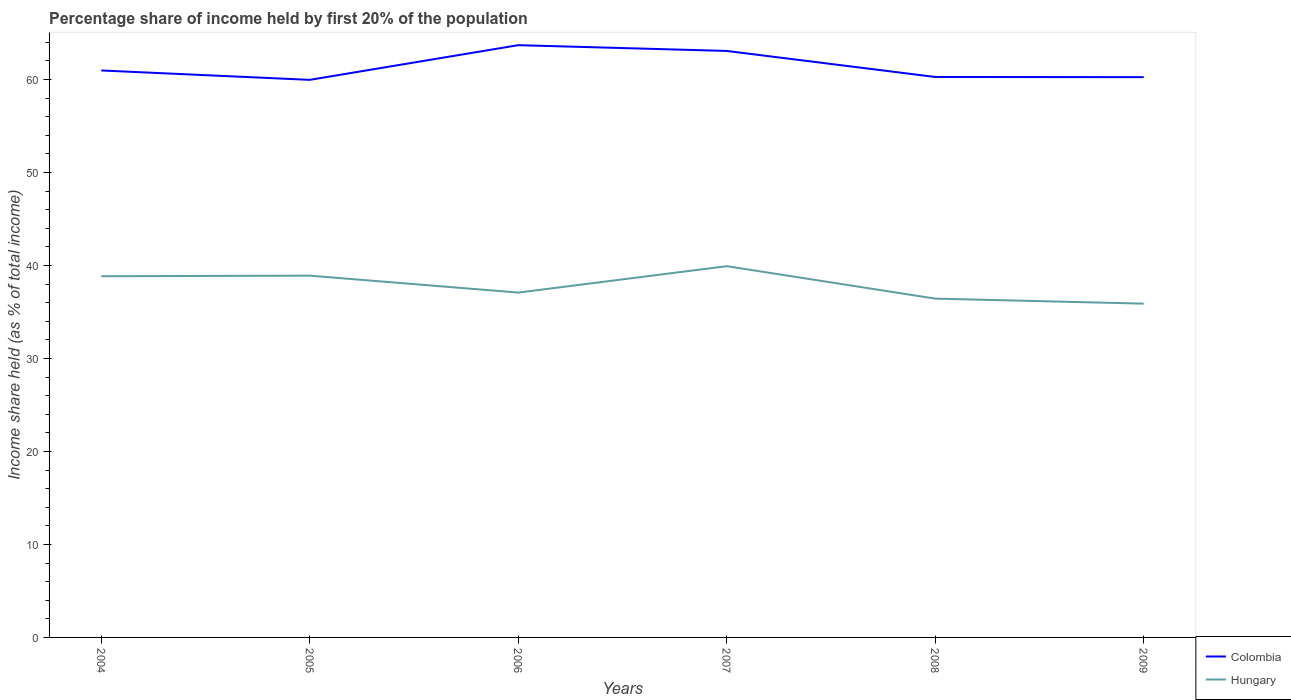How many different coloured lines are there?
Give a very brief answer. 2. Does the line corresponding to Hungary intersect with the line corresponding to Colombia?
Your answer should be compact. No. Is the number of lines equal to the number of legend labels?
Make the answer very short. Yes. Across all years, what is the maximum share of income held by first 20% of the population in Colombia?
Offer a terse response. 59.97. In which year was the share of income held by first 20% of the population in Colombia maximum?
Keep it short and to the point. 2005. What is the total share of income held by first 20% of the population in Colombia in the graph?
Give a very brief answer. 0.72. What is the difference between the highest and the second highest share of income held by first 20% of the population in Hungary?
Your answer should be compact. 4.03. Is the share of income held by first 20% of the population in Hungary strictly greater than the share of income held by first 20% of the population in Colombia over the years?
Ensure brevity in your answer.  Yes. How many lines are there?
Keep it short and to the point. 2. Does the graph contain any zero values?
Give a very brief answer. No. Does the graph contain grids?
Your response must be concise. No. Where does the legend appear in the graph?
Keep it short and to the point. Bottom right. How many legend labels are there?
Give a very brief answer. 2. How are the legend labels stacked?
Offer a very short reply. Vertical. What is the title of the graph?
Provide a short and direct response. Percentage share of income held by first 20% of the population. What is the label or title of the X-axis?
Offer a very short reply. Years. What is the label or title of the Y-axis?
Ensure brevity in your answer.  Income share held (as % of total income). What is the Income share held (as % of total income) of Colombia in 2004?
Your response must be concise. 60.98. What is the Income share held (as % of total income) in Hungary in 2004?
Provide a succinct answer. 38.85. What is the Income share held (as % of total income) in Colombia in 2005?
Ensure brevity in your answer.  59.97. What is the Income share held (as % of total income) of Hungary in 2005?
Keep it short and to the point. 38.91. What is the Income share held (as % of total income) of Colombia in 2006?
Ensure brevity in your answer.  63.7. What is the Income share held (as % of total income) in Hungary in 2006?
Provide a succinct answer. 37.09. What is the Income share held (as % of total income) in Colombia in 2007?
Your response must be concise. 63.08. What is the Income share held (as % of total income) of Hungary in 2007?
Your answer should be compact. 39.93. What is the Income share held (as % of total income) of Colombia in 2008?
Make the answer very short. 60.28. What is the Income share held (as % of total income) in Hungary in 2008?
Provide a short and direct response. 36.44. What is the Income share held (as % of total income) in Colombia in 2009?
Offer a very short reply. 60.26. What is the Income share held (as % of total income) of Hungary in 2009?
Give a very brief answer. 35.9. Across all years, what is the maximum Income share held (as % of total income) in Colombia?
Offer a very short reply. 63.7. Across all years, what is the maximum Income share held (as % of total income) of Hungary?
Give a very brief answer. 39.93. Across all years, what is the minimum Income share held (as % of total income) in Colombia?
Your answer should be very brief. 59.97. Across all years, what is the minimum Income share held (as % of total income) in Hungary?
Offer a very short reply. 35.9. What is the total Income share held (as % of total income) in Colombia in the graph?
Keep it short and to the point. 368.27. What is the total Income share held (as % of total income) in Hungary in the graph?
Keep it short and to the point. 227.12. What is the difference between the Income share held (as % of total income) of Hungary in 2004 and that in 2005?
Your response must be concise. -0.06. What is the difference between the Income share held (as % of total income) in Colombia in 2004 and that in 2006?
Offer a terse response. -2.72. What is the difference between the Income share held (as % of total income) of Hungary in 2004 and that in 2006?
Offer a very short reply. 1.76. What is the difference between the Income share held (as % of total income) in Colombia in 2004 and that in 2007?
Make the answer very short. -2.1. What is the difference between the Income share held (as % of total income) in Hungary in 2004 and that in 2007?
Provide a succinct answer. -1.08. What is the difference between the Income share held (as % of total income) in Hungary in 2004 and that in 2008?
Your response must be concise. 2.41. What is the difference between the Income share held (as % of total income) in Colombia in 2004 and that in 2009?
Offer a very short reply. 0.72. What is the difference between the Income share held (as % of total income) of Hungary in 2004 and that in 2009?
Make the answer very short. 2.95. What is the difference between the Income share held (as % of total income) in Colombia in 2005 and that in 2006?
Keep it short and to the point. -3.73. What is the difference between the Income share held (as % of total income) in Hungary in 2005 and that in 2006?
Ensure brevity in your answer.  1.82. What is the difference between the Income share held (as % of total income) of Colombia in 2005 and that in 2007?
Your response must be concise. -3.11. What is the difference between the Income share held (as % of total income) in Hungary in 2005 and that in 2007?
Provide a succinct answer. -1.02. What is the difference between the Income share held (as % of total income) in Colombia in 2005 and that in 2008?
Provide a succinct answer. -0.31. What is the difference between the Income share held (as % of total income) of Hungary in 2005 and that in 2008?
Provide a short and direct response. 2.47. What is the difference between the Income share held (as % of total income) in Colombia in 2005 and that in 2009?
Provide a succinct answer. -0.29. What is the difference between the Income share held (as % of total income) of Hungary in 2005 and that in 2009?
Make the answer very short. 3.01. What is the difference between the Income share held (as % of total income) in Colombia in 2006 and that in 2007?
Offer a very short reply. 0.62. What is the difference between the Income share held (as % of total income) of Hungary in 2006 and that in 2007?
Offer a very short reply. -2.84. What is the difference between the Income share held (as % of total income) in Colombia in 2006 and that in 2008?
Your response must be concise. 3.42. What is the difference between the Income share held (as % of total income) in Hungary in 2006 and that in 2008?
Your answer should be compact. 0.65. What is the difference between the Income share held (as % of total income) in Colombia in 2006 and that in 2009?
Your answer should be very brief. 3.44. What is the difference between the Income share held (as % of total income) in Hungary in 2006 and that in 2009?
Provide a succinct answer. 1.19. What is the difference between the Income share held (as % of total income) in Colombia in 2007 and that in 2008?
Offer a very short reply. 2.8. What is the difference between the Income share held (as % of total income) of Hungary in 2007 and that in 2008?
Offer a very short reply. 3.49. What is the difference between the Income share held (as % of total income) in Colombia in 2007 and that in 2009?
Your answer should be very brief. 2.82. What is the difference between the Income share held (as % of total income) in Hungary in 2007 and that in 2009?
Your response must be concise. 4.03. What is the difference between the Income share held (as % of total income) of Colombia in 2008 and that in 2009?
Provide a short and direct response. 0.02. What is the difference between the Income share held (as % of total income) of Hungary in 2008 and that in 2009?
Give a very brief answer. 0.54. What is the difference between the Income share held (as % of total income) in Colombia in 2004 and the Income share held (as % of total income) in Hungary in 2005?
Give a very brief answer. 22.07. What is the difference between the Income share held (as % of total income) of Colombia in 2004 and the Income share held (as % of total income) of Hungary in 2006?
Your answer should be very brief. 23.89. What is the difference between the Income share held (as % of total income) in Colombia in 2004 and the Income share held (as % of total income) in Hungary in 2007?
Give a very brief answer. 21.05. What is the difference between the Income share held (as % of total income) of Colombia in 2004 and the Income share held (as % of total income) of Hungary in 2008?
Your answer should be compact. 24.54. What is the difference between the Income share held (as % of total income) in Colombia in 2004 and the Income share held (as % of total income) in Hungary in 2009?
Make the answer very short. 25.08. What is the difference between the Income share held (as % of total income) of Colombia in 2005 and the Income share held (as % of total income) of Hungary in 2006?
Keep it short and to the point. 22.88. What is the difference between the Income share held (as % of total income) of Colombia in 2005 and the Income share held (as % of total income) of Hungary in 2007?
Offer a very short reply. 20.04. What is the difference between the Income share held (as % of total income) in Colombia in 2005 and the Income share held (as % of total income) in Hungary in 2008?
Give a very brief answer. 23.53. What is the difference between the Income share held (as % of total income) of Colombia in 2005 and the Income share held (as % of total income) of Hungary in 2009?
Offer a very short reply. 24.07. What is the difference between the Income share held (as % of total income) of Colombia in 2006 and the Income share held (as % of total income) of Hungary in 2007?
Make the answer very short. 23.77. What is the difference between the Income share held (as % of total income) in Colombia in 2006 and the Income share held (as % of total income) in Hungary in 2008?
Your answer should be compact. 27.26. What is the difference between the Income share held (as % of total income) in Colombia in 2006 and the Income share held (as % of total income) in Hungary in 2009?
Make the answer very short. 27.8. What is the difference between the Income share held (as % of total income) in Colombia in 2007 and the Income share held (as % of total income) in Hungary in 2008?
Your response must be concise. 26.64. What is the difference between the Income share held (as % of total income) in Colombia in 2007 and the Income share held (as % of total income) in Hungary in 2009?
Your response must be concise. 27.18. What is the difference between the Income share held (as % of total income) in Colombia in 2008 and the Income share held (as % of total income) in Hungary in 2009?
Make the answer very short. 24.38. What is the average Income share held (as % of total income) in Colombia per year?
Offer a terse response. 61.38. What is the average Income share held (as % of total income) in Hungary per year?
Your answer should be very brief. 37.85. In the year 2004, what is the difference between the Income share held (as % of total income) in Colombia and Income share held (as % of total income) in Hungary?
Ensure brevity in your answer.  22.13. In the year 2005, what is the difference between the Income share held (as % of total income) in Colombia and Income share held (as % of total income) in Hungary?
Provide a short and direct response. 21.06. In the year 2006, what is the difference between the Income share held (as % of total income) in Colombia and Income share held (as % of total income) in Hungary?
Provide a succinct answer. 26.61. In the year 2007, what is the difference between the Income share held (as % of total income) in Colombia and Income share held (as % of total income) in Hungary?
Your response must be concise. 23.15. In the year 2008, what is the difference between the Income share held (as % of total income) of Colombia and Income share held (as % of total income) of Hungary?
Ensure brevity in your answer.  23.84. In the year 2009, what is the difference between the Income share held (as % of total income) in Colombia and Income share held (as % of total income) in Hungary?
Make the answer very short. 24.36. What is the ratio of the Income share held (as % of total income) in Colombia in 2004 to that in 2005?
Keep it short and to the point. 1.02. What is the ratio of the Income share held (as % of total income) of Hungary in 2004 to that in 2005?
Keep it short and to the point. 1. What is the ratio of the Income share held (as % of total income) in Colombia in 2004 to that in 2006?
Make the answer very short. 0.96. What is the ratio of the Income share held (as % of total income) of Hungary in 2004 to that in 2006?
Offer a terse response. 1.05. What is the ratio of the Income share held (as % of total income) in Colombia in 2004 to that in 2007?
Offer a very short reply. 0.97. What is the ratio of the Income share held (as % of total income) in Hungary in 2004 to that in 2007?
Your response must be concise. 0.97. What is the ratio of the Income share held (as % of total income) in Colombia in 2004 to that in 2008?
Offer a terse response. 1.01. What is the ratio of the Income share held (as % of total income) of Hungary in 2004 to that in 2008?
Your answer should be compact. 1.07. What is the ratio of the Income share held (as % of total income) of Colombia in 2004 to that in 2009?
Provide a succinct answer. 1.01. What is the ratio of the Income share held (as % of total income) in Hungary in 2004 to that in 2009?
Offer a very short reply. 1.08. What is the ratio of the Income share held (as % of total income) in Colombia in 2005 to that in 2006?
Ensure brevity in your answer.  0.94. What is the ratio of the Income share held (as % of total income) of Hungary in 2005 to that in 2006?
Your response must be concise. 1.05. What is the ratio of the Income share held (as % of total income) of Colombia in 2005 to that in 2007?
Keep it short and to the point. 0.95. What is the ratio of the Income share held (as % of total income) in Hungary in 2005 to that in 2007?
Provide a short and direct response. 0.97. What is the ratio of the Income share held (as % of total income) in Hungary in 2005 to that in 2008?
Make the answer very short. 1.07. What is the ratio of the Income share held (as % of total income) of Colombia in 2005 to that in 2009?
Offer a very short reply. 1. What is the ratio of the Income share held (as % of total income) of Hungary in 2005 to that in 2009?
Make the answer very short. 1.08. What is the ratio of the Income share held (as % of total income) in Colombia in 2006 to that in 2007?
Your answer should be very brief. 1.01. What is the ratio of the Income share held (as % of total income) in Hungary in 2006 to that in 2007?
Provide a succinct answer. 0.93. What is the ratio of the Income share held (as % of total income) in Colombia in 2006 to that in 2008?
Provide a succinct answer. 1.06. What is the ratio of the Income share held (as % of total income) of Hungary in 2006 to that in 2008?
Keep it short and to the point. 1.02. What is the ratio of the Income share held (as % of total income) in Colombia in 2006 to that in 2009?
Give a very brief answer. 1.06. What is the ratio of the Income share held (as % of total income) of Hungary in 2006 to that in 2009?
Your response must be concise. 1.03. What is the ratio of the Income share held (as % of total income) in Colombia in 2007 to that in 2008?
Provide a succinct answer. 1.05. What is the ratio of the Income share held (as % of total income) of Hungary in 2007 to that in 2008?
Your answer should be compact. 1.1. What is the ratio of the Income share held (as % of total income) of Colombia in 2007 to that in 2009?
Provide a succinct answer. 1.05. What is the ratio of the Income share held (as % of total income) of Hungary in 2007 to that in 2009?
Ensure brevity in your answer.  1.11. What is the ratio of the Income share held (as % of total income) of Colombia in 2008 to that in 2009?
Your answer should be very brief. 1. What is the difference between the highest and the second highest Income share held (as % of total income) of Colombia?
Your response must be concise. 0.62. What is the difference between the highest and the lowest Income share held (as % of total income) of Colombia?
Your answer should be very brief. 3.73. What is the difference between the highest and the lowest Income share held (as % of total income) of Hungary?
Offer a terse response. 4.03. 